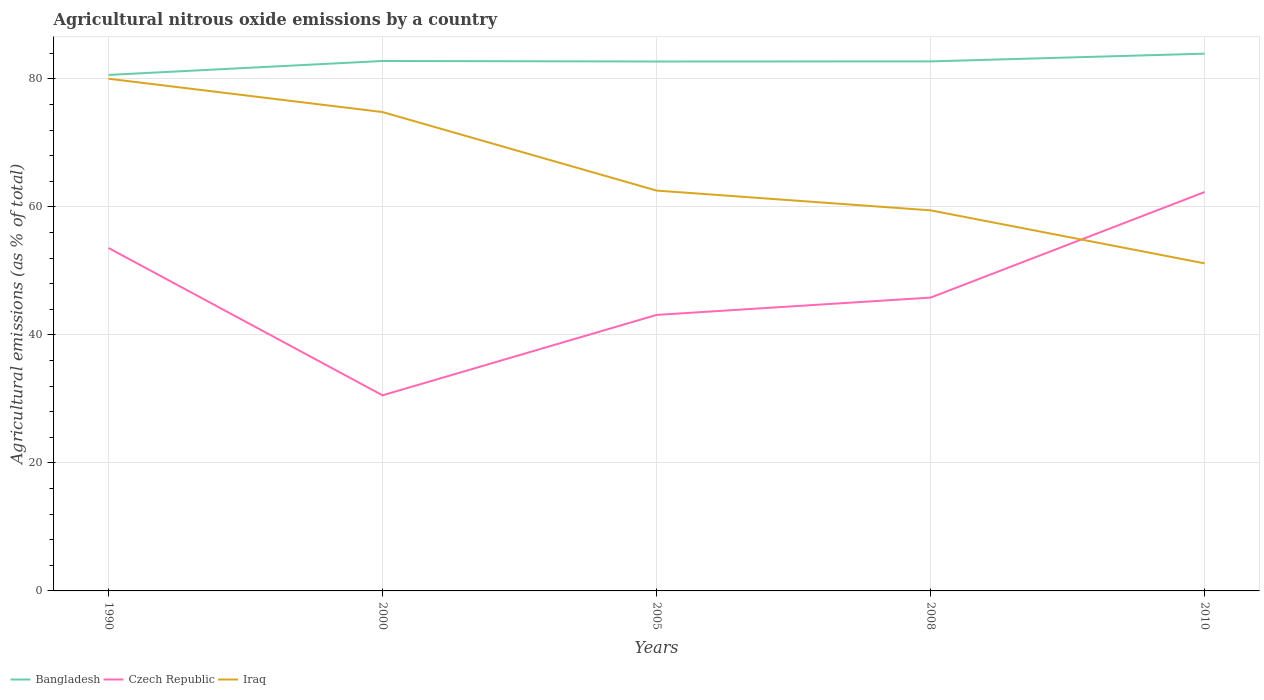Is the number of lines equal to the number of legend labels?
Your response must be concise. Yes. Across all years, what is the maximum amount of agricultural nitrous oxide emitted in Bangladesh?
Give a very brief answer. 80.63. In which year was the amount of agricultural nitrous oxide emitted in Czech Republic maximum?
Your answer should be very brief. 2000. What is the total amount of agricultural nitrous oxide emitted in Czech Republic in the graph?
Your response must be concise. -8.74. What is the difference between the highest and the second highest amount of agricultural nitrous oxide emitted in Czech Republic?
Make the answer very short. 31.77. What is the difference between the highest and the lowest amount of agricultural nitrous oxide emitted in Bangladesh?
Your answer should be very brief. 4. How many lines are there?
Your answer should be very brief. 3. What is the difference between two consecutive major ticks on the Y-axis?
Offer a terse response. 20. Are the values on the major ticks of Y-axis written in scientific E-notation?
Your answer should be very brief. No. Where does the legend appear in the graph?
Your answer should be very brief. Bottom left. How many legend labels are there?
Provide a short and direct response. 3. What is the title of the graph?
Your answer should be compact. Agricultural nitrous oxide emissions by a country. Does "Cuba" appear as one of the legend labels in the graph?
Provide a succinct answer. No. What is the label or title of the X-axis?
Provide a short and direct response. Years. What is the label or title of the Y-axis?
Your answer should be compact. Agricultural emissions (as % of total). What is the Agricultural emissions (as % of total) of Bangladesh in 1990?
Provide a short and direct response. 80.63. What is the Agricultural emissions (as % of total) in Czech Republic in 1990?
Your response must be concise. 53.6. What is the Agricultural emissions (as % of total) in Iraq in 1990?
Offer a very short reply. 80.04. What is the Agricultural emissions (as % of total) of Bangladesh in 2000?
Offer a very short reply. 82.81. What is the Agricultural emissions (as % of total) of Czech Republic in 2000?
Your answer should be very brief. 30.56. What is the Agricultural emissions (as % of total) in Iraq in 2000?
Make the answer very short. 74.83. What is the Agricultural emissions (as % of total) in Bangladesh in 2005?
Make the answer very short. 82.73. What is the Agricultural emissions (as % of total) in Czech Republic in 2005?
Offer a very short reply. 43.13. What is the Agricultural emissions (as % of total) in Iraq in 2005?
Keep it short and to the point. 62.56. What is the Agricultural emissions (as % of total) in Bangladesh in 2008?
Keep it short and to the point. 82.75. What is the Agricultural emissions (as % of total) in Czech Republic in 2008?
Offer a very short reply. 45.84. What is the Agricultural emissions (as % of total) of Iraq in 2008?
Provide a succinct answer. 59.47. What is the Agricultural emissions (as % of total) in Bangladesh in 2010?
Your response must be concise. 83.96. What is the Agricultural emissions (as % of total) in Czech Republic in 2010?
Make the answer very short. 62.33. What is the Agricultural emissions (as % of total) in Iraq in 2010?
Your response must be concise. 51.18. Across all years, what is the maximum Agricultural emissions (as % of total) in Bangladesh?
Your response must be concise. 83.96. Across all years, what is the maximum Agricultural emissions (as % of total) in Czech Republic?
Your answer should be very brief. 62.33. Across all years, what is the maximum Agricultural emissions (as % of total) of Iraq?
Keep it short and to the point. 80.04. Across all years, what is the minimum Agricultural emissions (as % of total) of Bangladesh?
Your answer should be compact. 80.63. Across all years, what is the minimum Agricultural emissions (as % of total) of Czech Republic?
Keep it short and to the point. 30.56. Across all years, what is the minimum Agricultural emissions (as % of total) in Iraq?
Ensure brevity in your answer.  51.18. What is the total Agricultural emissions (as % of total) in Bangladesh in the graph?
Ensure brevity in your answer.  412.87. What is the total Agricultural emissions (as % of total) of Czech Republic in the graph?
Offer a very short reply. 235.46. What is the total Agricultural emissions (as % of total) of Iraq in the graph?
Ensure brevity in your answer.  328.08. What is the difference between the Agricultural emissions (as % of total) of Bangladesh in 1990 and that in 2000?
Make the answer very short. -2.18. What is the difference between the Agricultural emissions (as % of total) of Czech Republic in 1990 and that in 2000?
Provide a short and direct response. 23.03. What is the difference between the Agricultural emissions (as % of total) in Iraq in 1990 and that in 2000?
Provide a succinct answer. 5.21. What is the difference between the Agricultural emissions (as % of total) of Bangladesh in 1990 and that in 2005?
Ensure brevity in your answer.  -2.1. What is the difference between the Agricultural emissions (as % of total) of Czech Republic in 1990 and that in 2005?
Offer a very short reply. 10.47. What is the difference between the Agricultural emissions (as % of total) of Iraq in 1990 and that in 2005?
Your answer should be compact. 17.48. What is the difference between the Agricultural emissions (as % of total) of Bangladesh in 1990 and that in 2008?
Your answer should be compact. -2.11. What is the difference between the Agricultural emissions (as % of total) in Czech Republic in 1990 and that in 2008?
Provide a succinct answer. 7.76. What is the difference between the Agricultural emissions (as % of total) in Iraq in 1990 and that in 2008?
Offer a very short reply. 20.57. What is the difference between the Agricultural emissions (as % of total) in Bangladesh in 1990 and that in 2010?
Offer a very short reply. -3.32. What is the difference between the Agricultural emissions (as % of total) in Czech Republic in 1990 and that in 2010?
Keep it short and to the point. -8.74. What is the difference between the Agricultural emissions (as % of total) of Iraq in 1990 and that in 2010?
Provide a succinct answer. 28.86. What is the difference between the Agricultural emissions (as % of total) of Bangladesh in 2000 and that in 2005?
Your answer should be compact. 0.08. What is the difference between the Agricultural emissions (as % of total) of Czech Republic in 2000 and that in 2005?
Offer a terse response. -12.57. What is the difference between the Agricultural emissions (as % of total) of Iraq in 2000 and that in 2005?
Offer a terse response. 12.27. What is the difference between the Agricultural emissions (as % of total) of Bangladesh in 2000 and that in 2008?
Offer a very short reply. 0.06. What is the difference between the Agricultural emissions (as % of total) of Czech Republic in 2000 and that in 2008?
Provide a short and direct response. -15.27. What is the difference between the Agricultural emissions (as % of total) in Iraq in 2000 and that in 2008?
Offer a very short reply. 15.36. What is the difference between the Agricultural emissions (as % of total) in Bangladesh in 2000 and that in 2010?
Provide a short and direct response. -1.15. What is the difference between the Agricultural emissions (as % of total) of Czech Republic in 2000 and that in 2010?
Offer a terse response. -31.77. What is the difference between the Agricultural emissions (as % of total) of Iraq in 2000 and that in 2010?
Your answer should be very brief. 23.65. What is the difference between the Agricultural emissions (as % of total) in Bangladesh in 2005 and that in 2008?
Your answer should be very brief. -0.02. What is the difference between the Agricultural emissions (as % of total) in Czech Republic in 2005 and that in 2008?
Offer a very short reply. -2.71. What is the difference between the Agricultural emissions (as % of total) in Iraq in 2005 and that in 2008?
Your response must be concise. 3.09. What is the difference between the Agricultural emissions (as % of total) in Bangladesh in 2005 and that in 2010?
Offer a very short reply. -1.23. What is the difference between the Agricultural emissions (as % of total) of Czech Republic in 2005 and that in 2010?
Your response must be concise. -19.2. What is the difference between the Agricultural emissions (as % of total) of Iraq in 2005 and that in 2010?
Give a very brief answer. 11.38. What is the difference between the Agricultural emissions (as % of total) of Bangladesh in 2008 and that in 2010?
Offer a terse response. -1.21. What is the difference between the Agricultural emissions (as % of total) of Czech Republic in 2008 and that in 2010?
Make the answer very short. -16.49. What is the difference between the Agricultural emissions (as % of total) in Iraq in 2008 and that in 2010?
Your answer should be very brief. 8.29. What is the difference between the Agricultural emissions (as % of total) of Bangladesh in 1990 and the Agricultural emissions (as % of total) of Czech Republic in 2000?
Your response must be concise. 50.07. What is the difference between the Agricultural emissions (as % of total) in Bangladesh in 1990 and the Agricultural emissions (as % of total) in Iraq in 2000?
Offer a terse response. 5.8. What is the difference between the Agricultural emissions (as % of total) in Czech Republic in 1990 and the Agricultural emissions (as % of total) in Iraq in 2000?
Offer a very short reply. -21.23. What is the difference between the Agricultural emissions (as % of total) in Bangladesh in 1990 and the Agricultural emissions (as % of total) in Czech Republic in 2005?
Make the answer very short. 37.5. What is the difference between the Agricultural emissions (as % of total) in Bangladesh in 1990 and the Agricultural emissions (as % of total) in Iraq in 2005?
Provide a short and direct response. 18.07. What is the difference between the Agricultural emissions (as % of total) in Czech Republic in 1990 and the Agricultural emissions (as % of total) in Iraq in 2005?
Provide a short and direct response. -8.96. What is the difference between the Agricultural emissions (as % of total) of Bangladesh in 1990 and the Agricultural emissions (as % of total) of Czech Republic in 2008?
Ensure brevity in your answer.  34.79. What is the difference between the Agricultural emissions (as % of total) of Bangladesh in 1990 and the Agricultural emissions (as % of total) of Iraq in 2008?
Ensure brevity in your answer.  21.16. What is the difference between the Agricultural emissions (as % of total) in Czech Republic in 1990 and the Agricultural emissions (as % of total) in Iraq in 2008?
Provide a short and direct response. -5.87. What is the difference between the Agricultural emissions (as % of total) in Bangladesh in 1990 and the Agricultural emissions (as % of total) in Czech Republic in 2010?
Your answer should be very brief. 18.3. What is the difference between the Agricultural emissions (as % of total) in Bangladesh in 1990 and the Agricultural emissions (as % of total) in Iraq in 2010?
Your response must be concise. 29.45. What is the difference between the Agricultural emissions (as % of total) in Czech Republic in 1990 and the Agricultural emissions (as % of total) in Iraq in 2010?
Keep it short and to the point. 2.41. What is the difference between the Agricultural emissions (as % of total) of Bangladesh in 2000 and the Agricultural emissions (as % of total) of Czech Republic in 2005?
Ensure brevity in your answer.  39.68. What is the difference between the Agricultural emissions (as % of total) of Bangladesh in 2000 and the Agricultural emissions (as % of total) of Iraq in 2005?
Your response must be concise. 20.25. What is the difference between the Agricultural emissions (as % of total) in Czech Republic in 2000 and the Agricultural emissions (as % of total) in Iraq in 2005?
Your response must be concise. -31.99. What is the difference between the Agricultural emissions (as % of total) of Bangladesh in 2000 and the Agricultural emissions (as % of total) of Czech Republic in 2008?
Ensure brevity in your answer.  36.97. What is the difference between the Agricultural emissions (as % of total) of Bangladesh in 2000 and the Agricultural emissions (as % of total) of Iraq in 2008?
Make the answer very short. 23.34. What is the difference between the Agricultural emissions (as % of total) of Czech Republic in 2000 and the Agricultural emissions (as % of total) of Iraq in 2008?
Your answer should be compact. -28.91. What is the difference between the Agricultural emissions (as % of total) in Bangladesh in 2000 and the Agricultural emissions (as % of total) in Czech Republic in 2010?
Provide a succinct answer. 20.48. What is the difference between the Agricultural emissions (as % of total) of Bangladesh in 2000 and the Agricultural emissions (as % of total) of Iraq in 2010?
Your answer should be compact. 31.63. What is the difference between the Agricultural emissions (as % of total) in Czech Republic in 2000 and the Agricultural emissions (as % of total) in Iraq in 2010?
Your answer should be compact. -20.62. What is the difference between the Agricultural emissions (as % of total) of Bangladesh in 2005 and the Agricultural emissions (as % of total) of Czech Republic in 2008?
Keep it short and to the point. 36.89. What is the difference between the Agricultural emissions (as % of total) of Bangladesh in 2005 and the Agricultural emissions (as % of total) of Iraq in 2008?
Offer a very short reply. 23.26. What is the difference between the Agricultural emissions (as % of total) of Czech Republic in 2005 and the Agricultural emissions (as % of total) of Iraq in 2008?
Keep it short and to the point. -16.34. What is the difference between the Agricultural emissions (as % of total) of Bangladesh in 2005 and the Agricultural emissions (as % of total) of Czech Republic in 2010?
Give a very brief answer. 20.4. What is the difference between the Agricultural emissions (as % of total) in Bangladesh in 2005 and the Agricultural emissions (as % of total) in Iraq in 2010?
Ensure brevity in your answer.  31.55. What is the difference between the Agricultural emissions (as % of total) of Czech Republic in 2005 and the Agricultural emissions (as % of total) of Iraq in 2010?
Offer a very short reply. -8.05. What is the difference between the Agricultural emissions (as % of total) in Bangladesh in 2008 and the Agricultural emissions (as % of total) in Czech Republic in 2010?
Your answer should be compact. 20.41. What is the difference between the Agricultural emissions (as % of total) in Bangladesh in 2008 and the Agricultural emissions (as % of total) in Iraq in 2010?
Ensure brevity in your answer.  31.56. What is the difference between the Agricultural emissions (as % of total) in Czech Republic in 2008 and the Agricultural emissions (as % of total) in Iraq in 2010?
Keep it short and to the point. -5.34. What is the average Agricultural emissions (as % of total) in Bangladesh per year?
Provide a succinct answer. 82.57. What is the average Agricultural emissions (as % of total) of Czech Republic per year?
Provide a succinct answer. 47.09. What is the average Agricultural emissions (as % of total) in Iraq per year?
Your answer should be very brief. 65.62. In the year 1990, what is the difference between the Agricultural emissions (as % of total) in Bangladesh and Agricultural emissions (as % of total) in Czech Republic?
Offer a very short reply. 27.04. In the year 1990, what is the difference between the Agricultural emissions (as % of total) in Bangladesh and Agricultural emissions (as % of total) in Iraq?
Provide a succinct answer. 0.59. In the year 1990, what is the difference between the Agricultural emissions (as % of total) in Czech Republic and Agricultural emissions (as % of total) in Iraq?
Give a very brief answer. -26.44. In the year 2000, what is the difference between the Agricultural emissions (as % of total) in Bangladesh and Agricultural emissions (as % of total) in Czech Republic?
Your answer should be compact. 52.24. In the year 2000, what is the difference between the Agricultural emissions (as % of total) in Bangladesh and Agricultural emissions (as % of total) in Iraq?
Your answer should be compact. 7.98. In the year 2000, what is the difference between the Agricultural emissions (as % of total) of Czech Republic and Agricultural emissions (as % of total) of Iraq?
Offer a very short reply. -44.26. In the year 2005, what is the difference between the Agricultural emissions (as % of total) in Bangladesh and Agricultural emissions (as % of total) in Czech Republic?
Your answer should be compact. 39.6. In the year 2005, what is the difference between the Agricultural emissions (as % of total) of Bangladesh and Agricultural emissions (as % of total) of Iraq?
Your answer should be very brief. 20.17. In the year 2005, what is the difference between the Agricultural emissions (as % of total) of Czech Republic and Agricultural emissions (as % of total) of Iraq?
Offer a very short reply. -19.43. In the year 2008, what is the difference between the Agricultural emissions (as % of total) in Bangladesh and Agricultural emissions (as % of total) in Czech Republic?
Your answer should be compact. 36.91. In the year 2008, what is the difference between the Agricultural emissions (as % of total) in Bangladesh and Agricultural emissions (as % of total) in Iraq?
Your response must be concise. 23.28. In the year 2008, what is the difference between the Agricultural emissions (as % of total) of Czech Republic and Agricultural emissions (as % of total) of Iraq?
Your answer should be compact. -13.63. In the year 2010, what is the difference between the Agricultural emissions (as % of total) of Bangladesh and Agricultural emissions (as % of total) of Czech Republic?
Make the answer very short. 21.62. In the year 2010, what is the difference between the Agricultural emissions (as % of total) in Bangladesh and Agricultural emissions (as % of total) in Iraq?
Provide a succinct answer. 32.77. In the year 2010, what is the difference between the Agricultural emissions (as % of total) in Czech Republic and Agricultural emissions (as % of total) in Iraq?
Keep it short and to the point. 11.15. What is the ratio of the Agricultural emissions (as % of total) of Bangladesh in 1990 to that in 2000?
Your answer should be compact. 0.97. What is the ratio of the Agricultural emissions (as % of total) in Czech Republic in 1990 to that in 2000?
Your answer should be compact. 1.75. What is the ratio of the Agricultural emissions (as % of total) in Iraq in 1990 to that in 2000?
Give a very brief answer. 1.07. What is the ratio of the Agricultural emissions (as % of total) of Bangladesh in 1990 to that in 2005?
Give a very brief answer. 0.97. What is the ratio of the Agricultural emissions (as % of total) in Czech Republic in 1990 to that in 2005?
Provide a short and direct response. 1.24. What is the ratio of the Agricultural emissions (as % of total) in Iraq in 1990 to that in 2005?
Your answer should be compact. 1.28. What is the ratio of the Agricultural emissions (as % of total) in Bangladesh in 1990 to that in 2008?
Give a very brief answer. 0.97. What is the ratio of the Agricultural emissions (as % of total) of Czech Republic in 1990 to that in 2008?
Make the answer very short. 1.17. What is the ratio of the Agricultural emissions (as % of total) in Iraq in 1990 to that in 2008?
Your answer should be very brief. 1.35. What is the ratio of the Agricultural emissions (as % of total) of Bangladesh in 1990 to that in 2010?
Ensure brevity in your answer.  0.96. What is the ratio of the Agricultural emissions (as % of total) in Czech Republic in 1990 to that in 2010?
Give a very brief answer. 0.86. What is the ratio of the Agricultural emissions (as % of total) of Iraq in 1990 to that in 2010?
Keep it short and to the point. 1.56. What is the ratio of the Agricultural emissions (as % of total) in Bangladesh in 2000 to that in 2005?
Keep it short and to the point. 1. What is the ratio of the Agricultural emissions (as % of total) in Czech Republic in 2000 to that in 2005?
Ensure brevity in your answer.  0.71. What is the ratio of the Agricultural emissions (as % of total) in Iraq in 2000 to that in 2005?
Your answer should be very brief. 1.2. What is the ratio of the Agricultural emissions (as % of total) in Bangladesh in 2000 to that in 2008?
Provide a short and direct response. 1. What is the ratio of the Agricultural emissions (as % of total) in Czech Republic in 2000 to that in 2008?
Provide a succinct answer. 0.67. What is the ratio of the Agricultural emissions (as % of total) of Iraq in 2000 to that in 2008?
Give a very brief answer. 1.26. What is the ratio of the Agricultural emissions (as % of total) of Bangladesh in 2000 to that in 2010?
Ensure brevity in your answer.  0.99. What is the ratio of the Agricultural emissions (as % of total) of Czech Republic in 2000 to that in 2010?
Keep it short and to the point. 0.49. What is the ratio of the Agricultural emissions (as % of total) of Iraq in 2000 to that in 2010?
Provide a succinct answer. 1.46. What is the ratio of the Agricultural emissions (as % of total) in Czech Republic in 2005 to that in 2008?
Offer a very short reply. 0.94. What is the ratio of the Agricultural emissions (as % of total) of Iraq in 2005 to that in 2008?
Offer a terse response. 1.05. What is the ratio of the Agricultural emissions (as % of total) in Bangladesh in 2005 to that in 2010?
Make the answer very short. 0.99. What is the ratio of the Agricultural emissions (as % of total) in Czech Republic in 2005 to that in 2010?
Offer a terse response. 0.69. What is the ratio of the Agricultural emissions (as % of total) of Iraq in 2005 to that in 2010?
Your response must be concise. 1.22. What is the ratio of the Agricultural emissions (as % of total) in Bangladesh in 2008 to that in 2010?
Your response must be concise. 0.99. What is the ratio of the Agricultural emissions (as % of total) in Czech Republic in 2008 to that in 2010?
Offer a terse response. 0.74. What is the ratio of the Agricultural emissions (as % of total) of Iraq in 2008 to that in 2010?
Offer a terse response. 1.16. What is the difference between the highest and the second highest Agricultural emissions (as % of total) of Bangladesh?
Provide a short and direct response. 1.15. What is the difference between the highest and the second highest Agricultural emissions (as % of total) of Czech Republic?
Offer a very short reply. 8.74. What is the difference between the highest and the second highest Agricultural emissions (as % of total) of Iraq?
Provide a short and direct response. 5.21. What is the difference between the highest and the lowest Agricultural emissions (as % of total) of Bangladesh?
Offer a terse response. 3.32. What is the difference between the highest and the lowest Agricultural emissions (as % of total) of Czech Republic?
Make the answer very short. 31.77. What is the difference between the highest and the lowest Agricultural emissions (as % of total) in Iraq?
Provide a succinct answer. 28.86. 